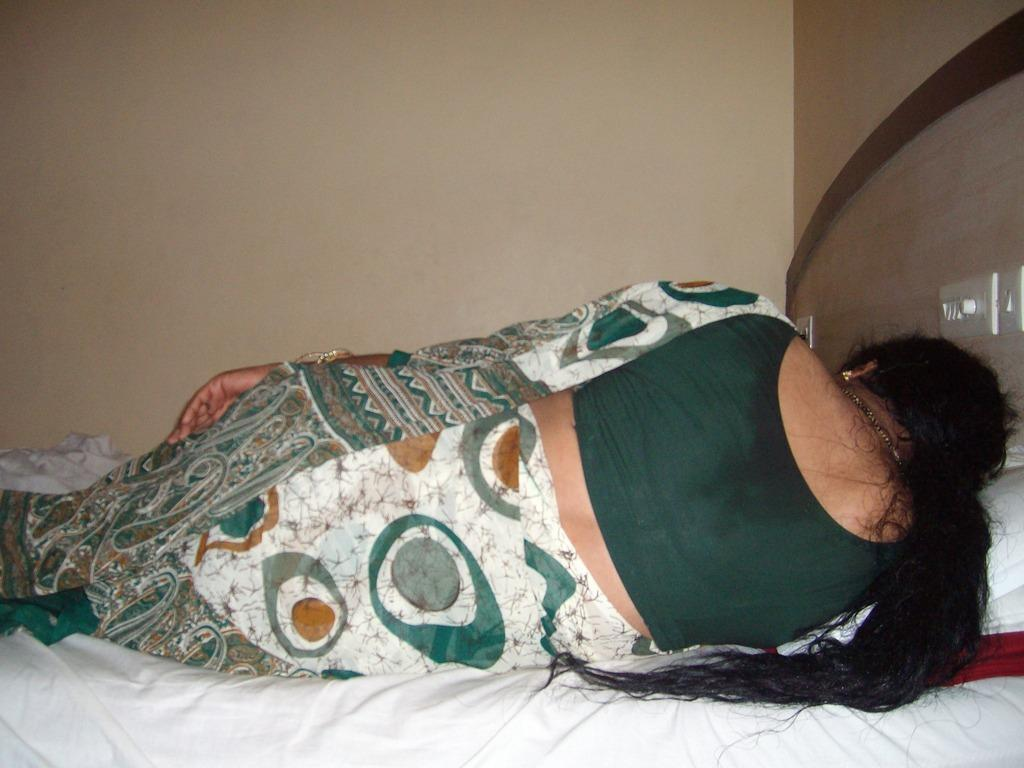What is the person in the image doing? There is a person sleeping on the bed in the image. Where are the switches located in relation to the bed? The switches are on the right side of the bed. What is visible at the top of the image? There is a wall at the top of the image. What type of bubble can be seen floating near the person in the image? There is no bubble present in the image; it only features a person sleeping on the bed, switches on the right side of the bed, and a wall at the top of the image. 